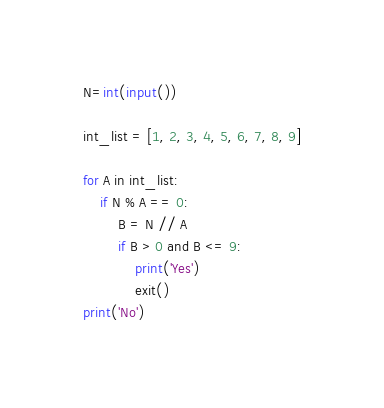Convert code to text. <code><loc_0><loc_0><loc_500><loc_500><_Python_>N=int(input())

int_list = [1, 2, 3, 4, 5, 6, 7, 8, 9]
 
for A in int_list:
    if N % A == 0:
        B = N // A
        if B > 0 and B <= 9:
            print('Yes')
            exit()
print('No')
</code> 